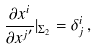<formula> <loc_0><loc_0><loc_500><loc_500>\frac { \partial x ^ { i } } { \partial x { ^ { j } } ^ { \prime } } | _ { \Sigma _ { 2 } } = \delta ^ { i } _ { j } \, ,</formula> 